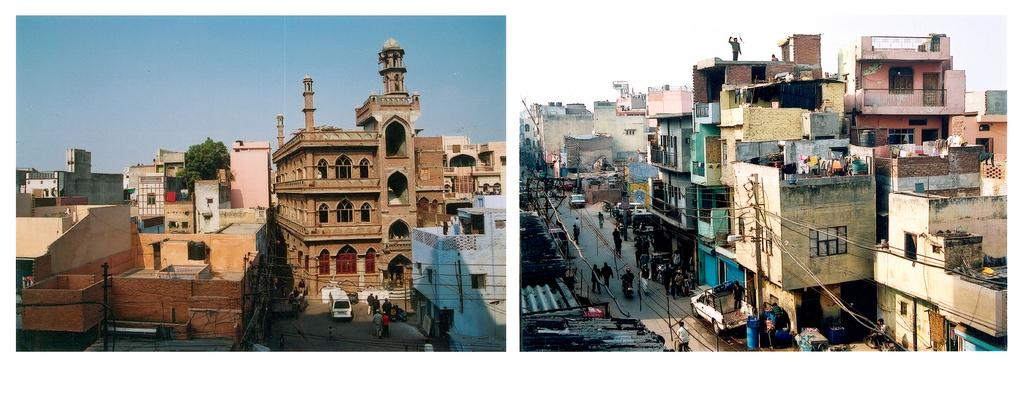How many pictures are in the image? The image consists of two pictures. What can be seen in both pictures? Both pictures contain buildings. What else is visible on the road in the image? There are vehicles and people on the road. What is the condition of the sky in the image? The sky is clear in the image. What type of vegetation is present in the image? There is a tree in the image. What type of game is being played under the arch in the image? There is no arch or game present in the image. 